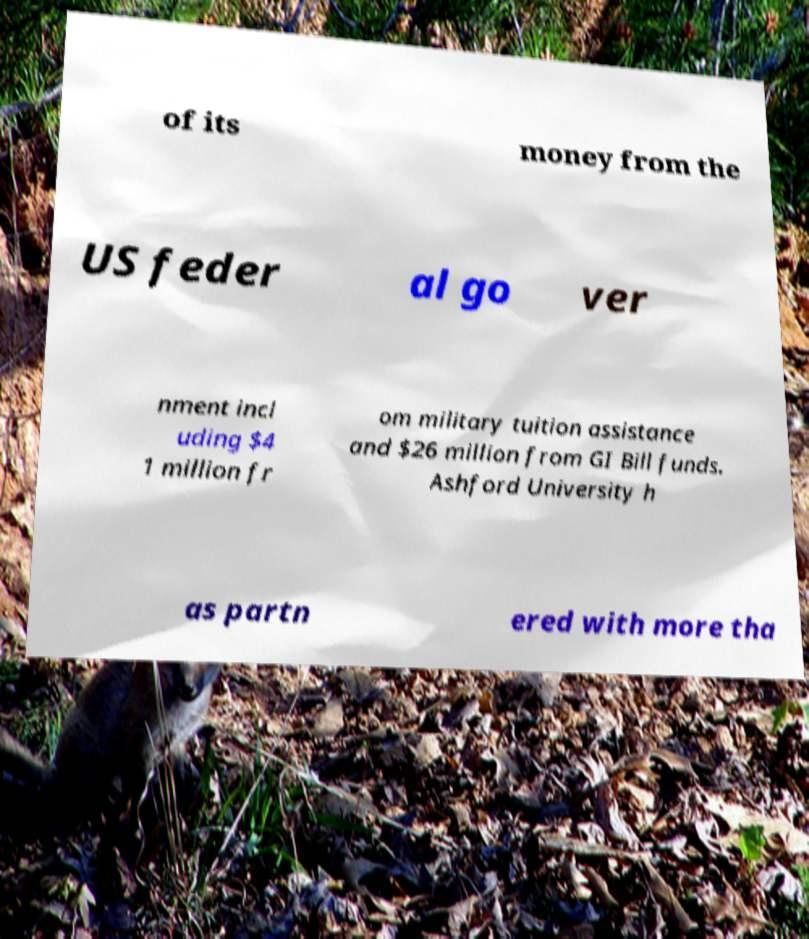There's text embedded in this image that I need extracted. Can you transcribe it verbatim? of its money from the US feder al go ver nment incl uding $4 1 million fr om military tuition assistance and $26 million from GI Bill funds. Ashford University h as partn ered with more tha 